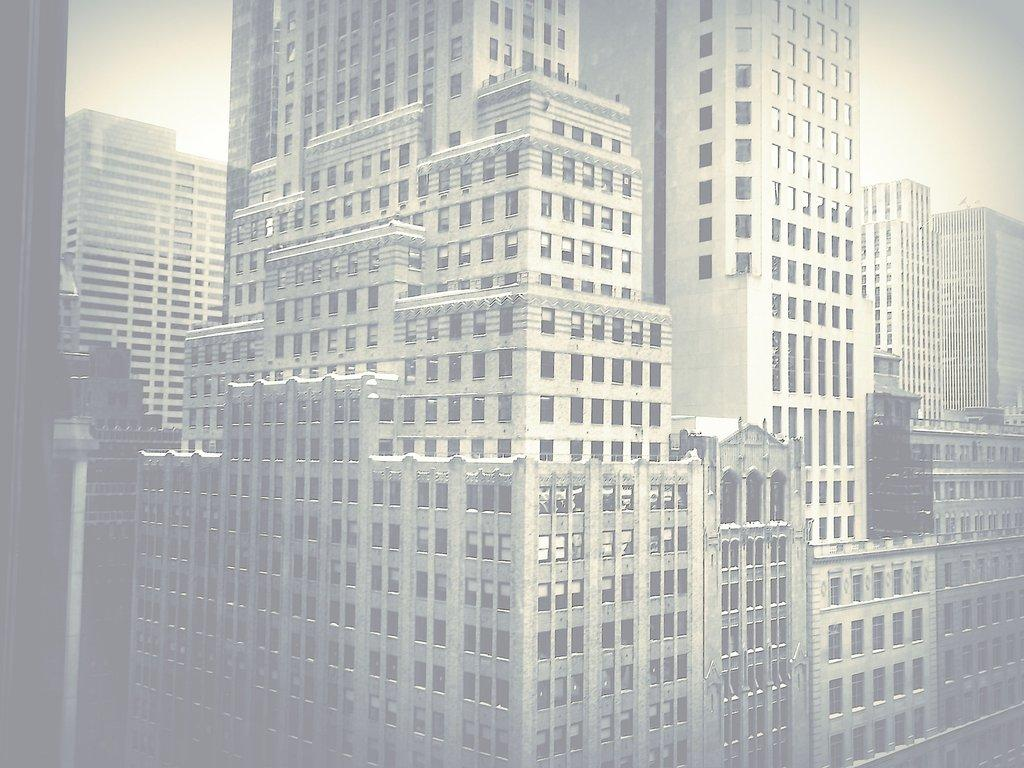What is the main subject of the image? The main subject of the image is buildings. Where are the buildings located in the image? The buildings are in the center of the image. Can you hear the sound of a railway in the image? There is no mention of a railway or any sound in the image, so it cannot be determined from the image alone. 